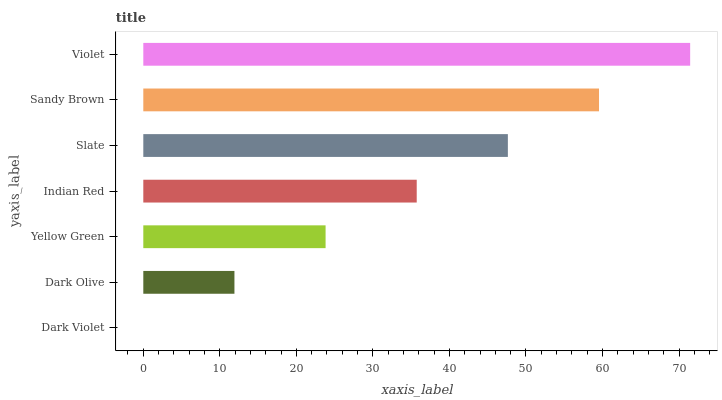Is Dark Violet the minimum?
Answer yes or no. Yes. Is Violet the maximum?
Answer yes or no. Yes. Is Dark Olive the minimum?
Answer yes or no. No. Is Dark Olive the maximum?
Answer yes or no. No. Is Dark Olive greater than Dark Violet?
Answer yes or no. Yes. Is Dark Violet less than Dark Olive?
Answer yes or no. Yes. Is Dark Violet greater than Dark Olive?
Answer yes or no. No. Is Dark Olive less than Dark Violet?
Answer yes or no. No. Is Indian Red the high median?
Answer yes or no. Yes. Is Indian Red the low median?
Answer yes or no. Yes. Is Yellow Green the high median?
Answer yes or no. No. Is Violet the low median?
Answer yes or no. No. 